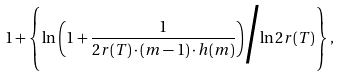Convert formula to latex. <formula><loc_0><loc_0><loc_500><loc_500>1 + \left \{ { \ln \left ( 1 + \frac { 1 } { { 2 r ( T ) } \cdot ( m - 1 ) \cdot h ( m ) } \right ) } \Big / { \ln { 2 r ( T ) } } \right \} ,</formula> 